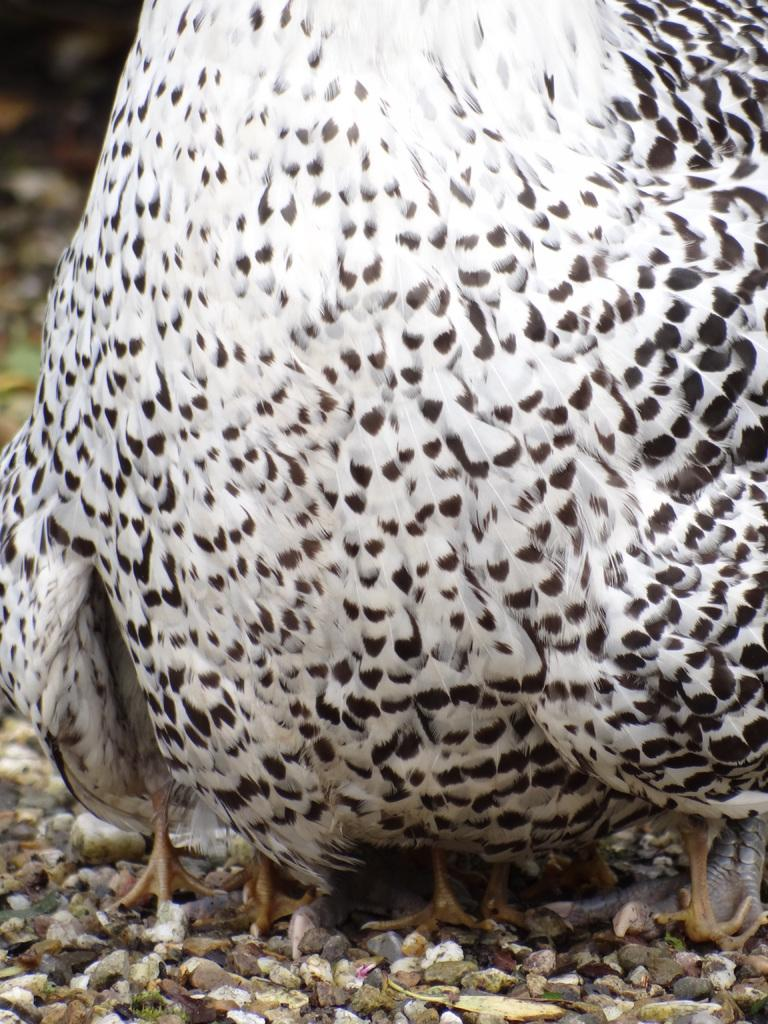What is the main subject of the image? The main subject of the image is a bird. Where is the bird located in the image? The bird is standing on the ground. What else can be seen on the ground in the image? There are stones on the ground. What type of road can be seen in the image? There is no road present in the image; it features a bird standing on the ground with stones. Where is the desk located in the image? There is no desk present in the image. 